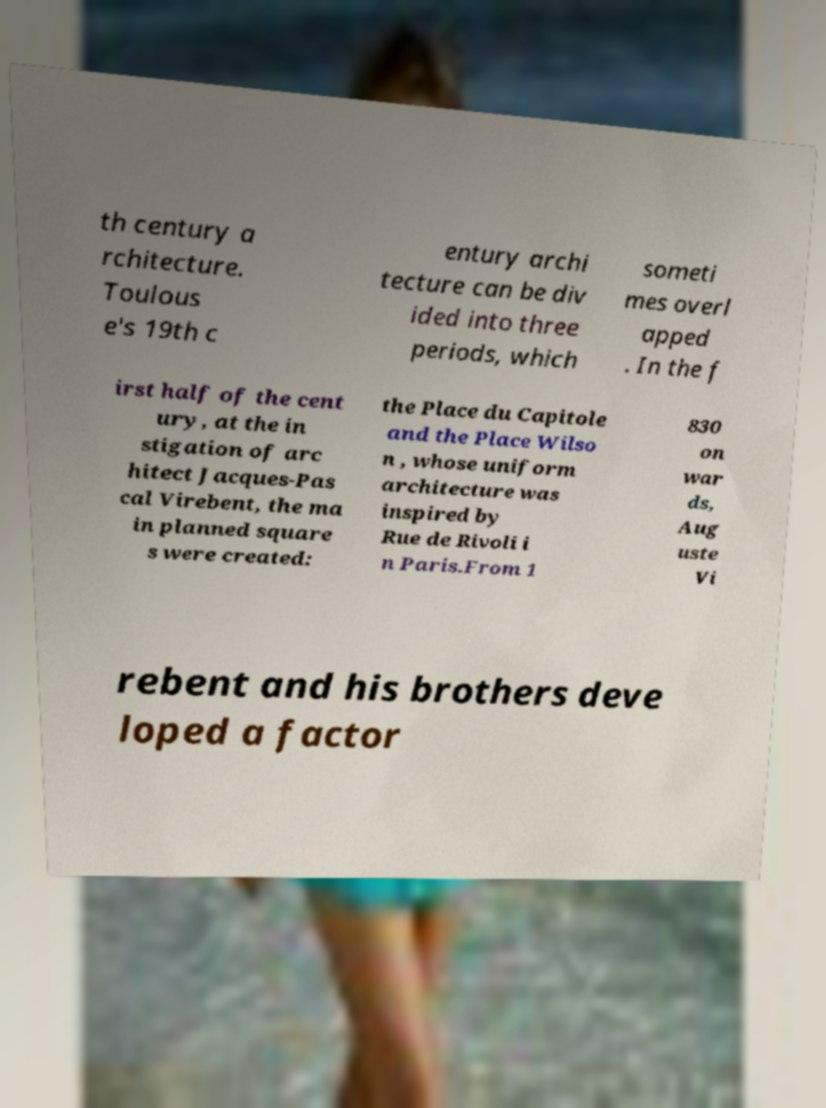For documentation purposes, I need the text within this image transcribed. Could you provide that? th century a rchitecture. Toulous e's 19th c entury archi tecture can be div ided into three periods, which someti mes overl apped . In the f irst half of the cent ury, at the in stigation of arc hitect Jacques-Pas cal Virebent, the ma in planned square s were created: the Place du Capitole and the Place Wilso n , whose uniform architecture was inspired by Rue de Rivoli i n Paris.From 1 830 on war ds, Aug uste Vi rebent and his brothers deve loped a factor 